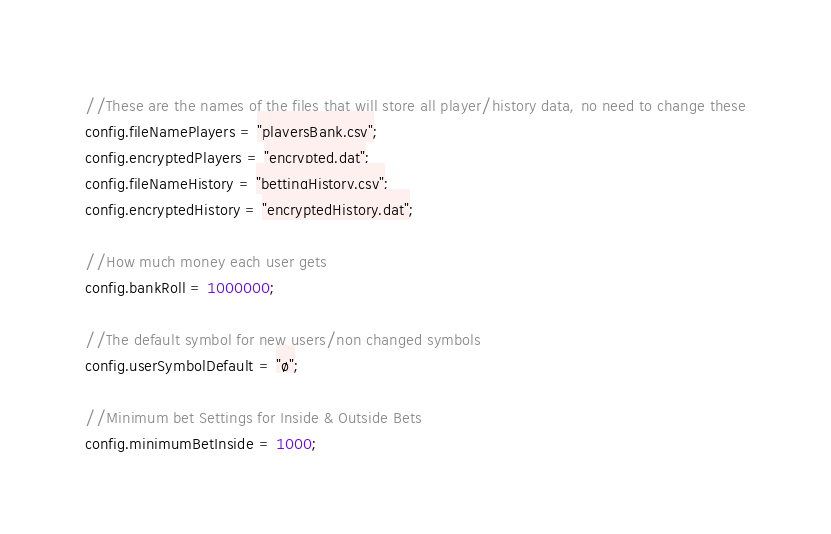<code> <loc_0><loc_0><loc_500><loc_500><_JavaScript_>//These are the names of the files that will store all player/history data, no need to change these
config.fileNamePlayers = "playersBank.csv";
config.encryptedPlayers = "encrypted.dat";
config.fileNameHistory = "bettingHistory.csv";
config.encryptedHistory = "encryptedHistory.dat";

//How much money each user gets
config.bankRoll = 1000000;

//The default symbol for new users/non changed symbols
config.userSymbolDefault = "ø";

//Minimum bet Settings for Inside & Outside Bets
config.minimumBetInside = 1000;</code> 